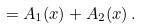Convert formula to latex. <formula><loc_0><loc_0><loc_500><loc_500>= A _ { 1 } ( x ) + A _ { 2 } ( x ) \, .</formula> 